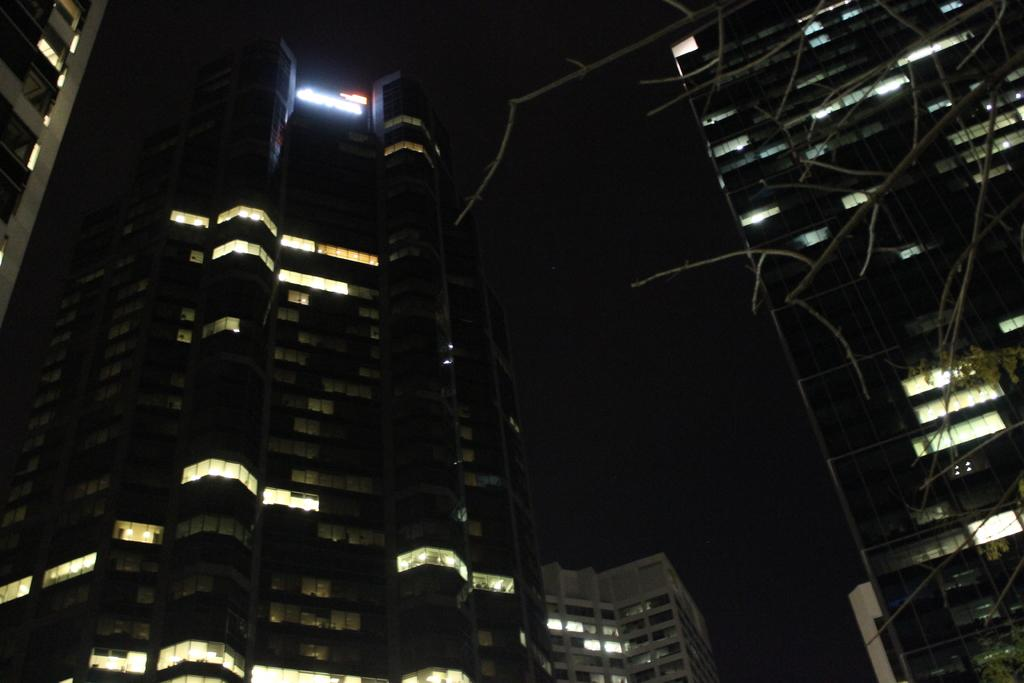What can be seen in the foreground of the image? There are stems of a tree in the foreground of the image. What is located in the center of the image? There are buildings in the center of the image. Can you describe any details about the buildings? Lights are visible in some rooms of the buildings. What is written or displayed at the top of the image? There is text at the top of the image. What type of blood is visible on the tree stems in the image? There is no blood visible on the tree stems in the image. What kind of pancake is being served in the buildings in the image? There is no pancake present in the image; the buildings have lights visible in some rooms. 